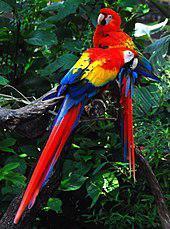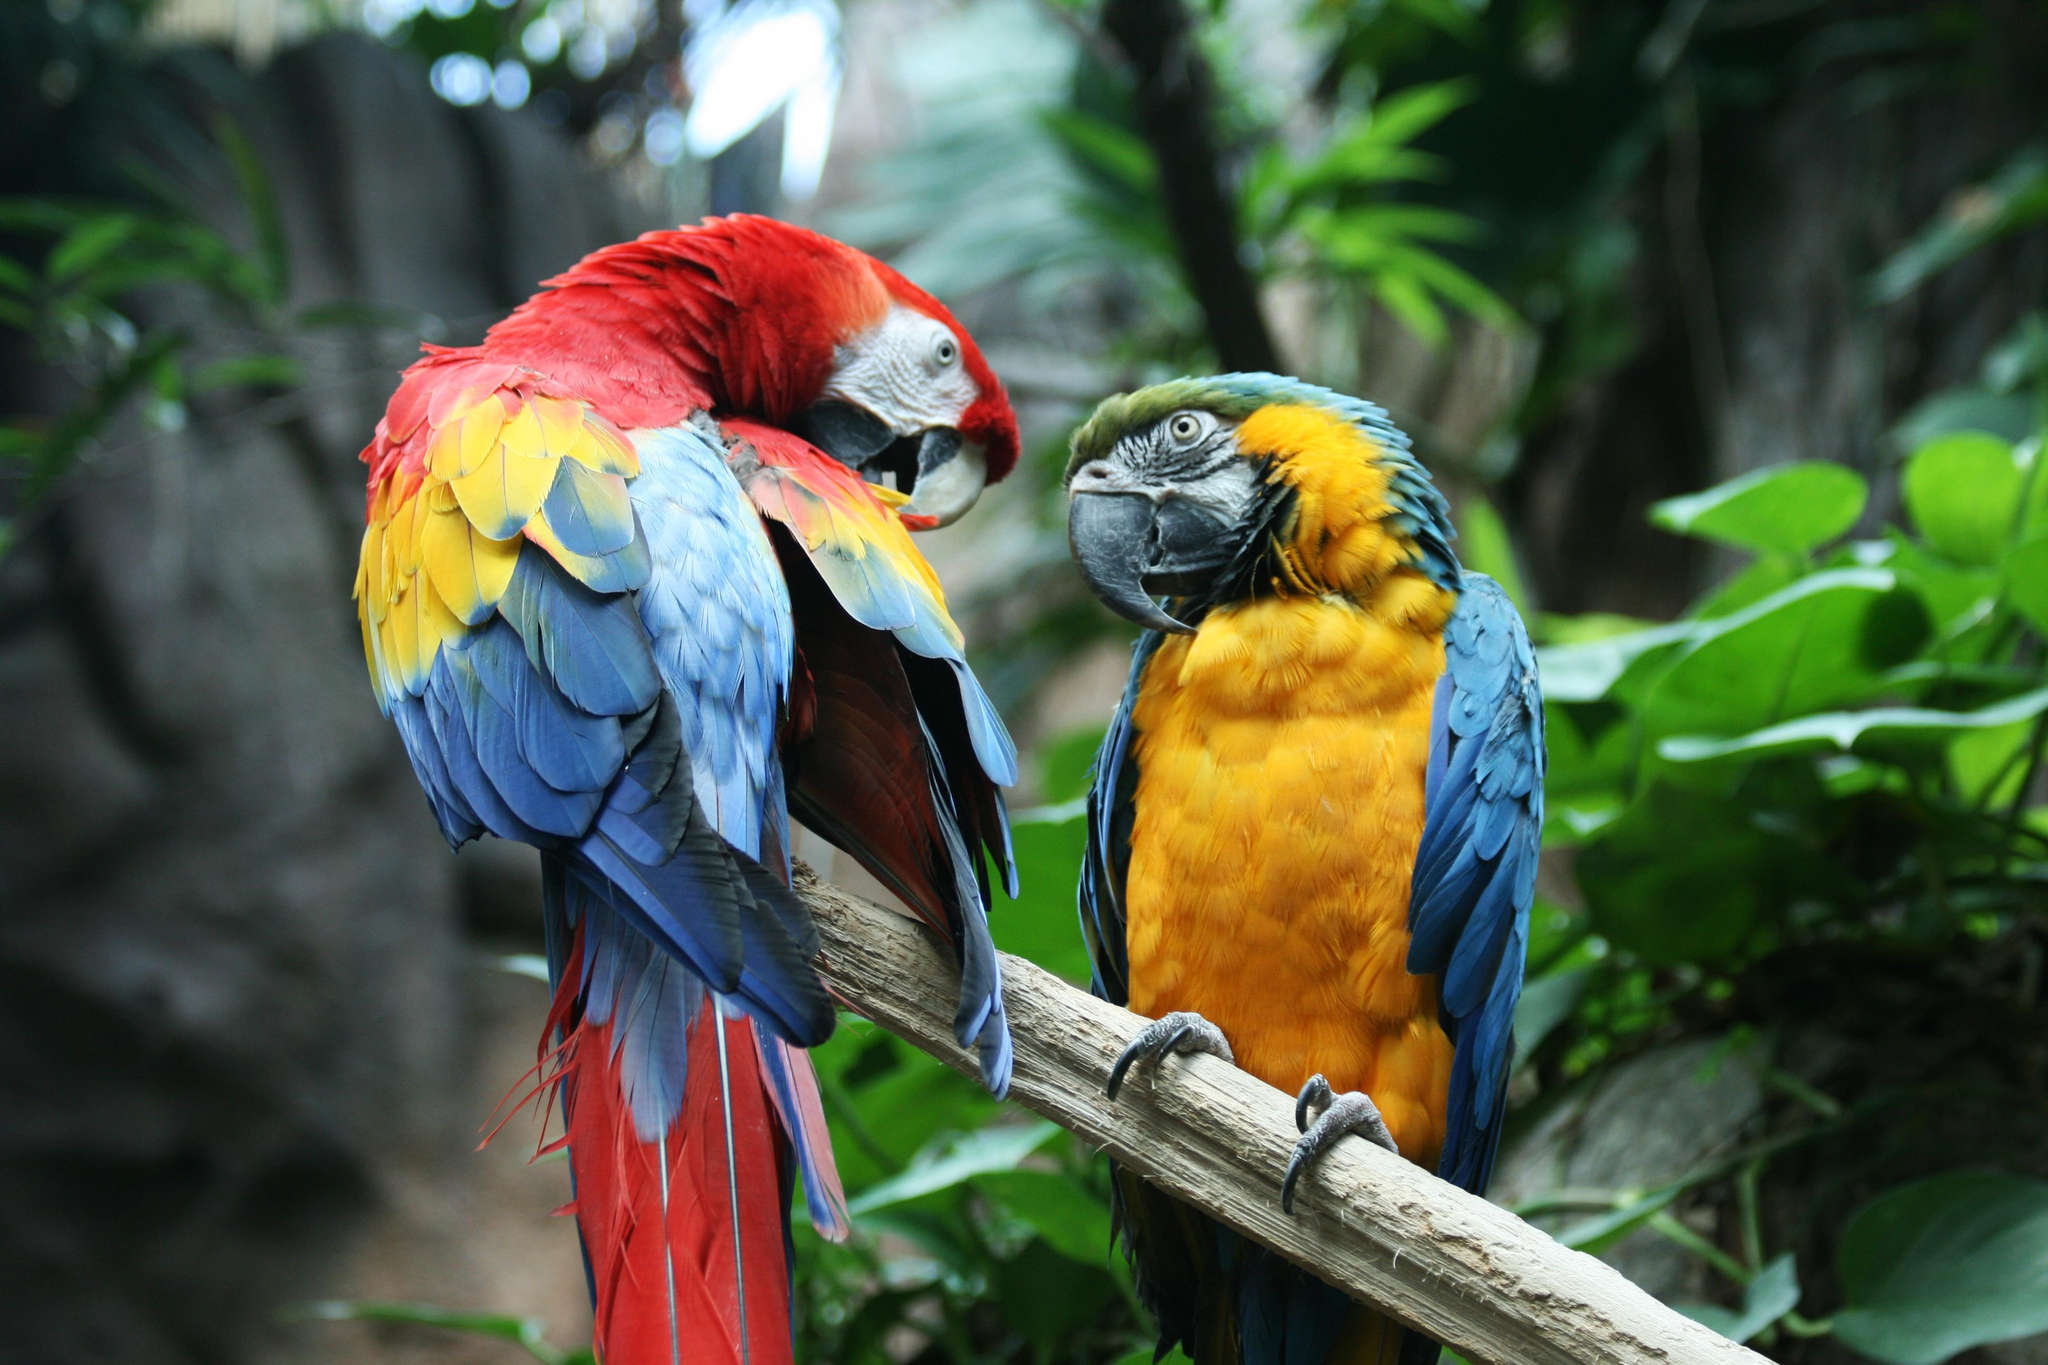The first image is the image on the left, the second image is the image on the right. For the images displayed, is the sentence "One of the images shows a red, yellow and blue parrot flying." factually correct? Answer yes or no. No. 